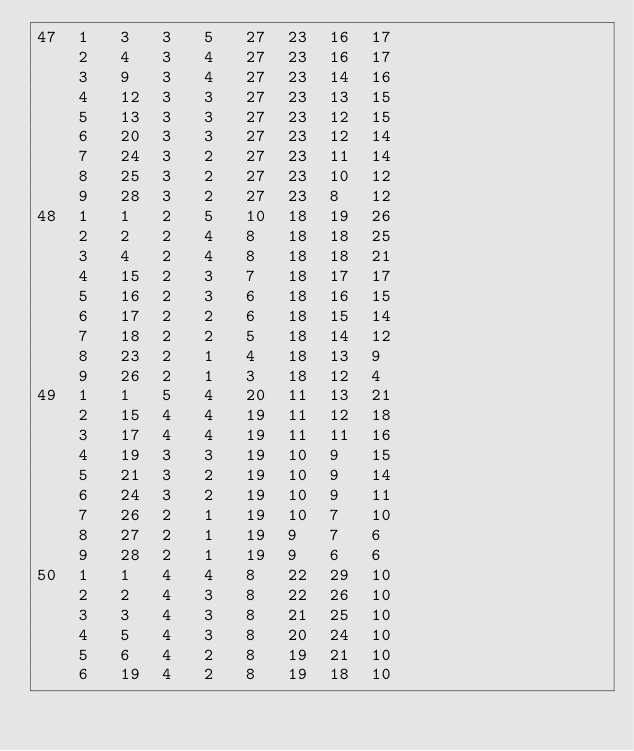Convert code to text. <code><loc_0><loc_0><loc_500><loc_500><_ObjectiveC_>47	1	3	3	5	27	23	16	17	
	2	4	3	4	27	23	16	17	
	3	9	3	4	27	23	14	16	
	4	12	3	3	27	23	13	15	
	5	13	3	3	27	23	12	15	
	6	20	3	3	27	23	12	14	
	7	24	3	2	27	23	11	14	
	8	25	3	2	27	23	10	12	
	9	28	3	2	27	23	8	12	
48	1	1	2	5	10	18	19	26	
	2	2	2	4	8	18	18	25	
	3	4	2	4	8	18	18	21	
	4	15	2	3	7	18	17	17	
	5	16	2	3	6	18	16	15	
	6	17	2	2	6	18	15	14	
	7	18	2	2	5	18	14	12	
	8	23	2	1	4	18	13	9	
	9	26	2	1	3	18	12	4	
49	1	1	5	4	20	11	13	21	
	2	15	4	4	19	11	12	18	
	3	17	4	4	19	11	11	16	
	4	19	3	3	19	10	9	15	
	5	21	3	2	19	10	9	14	
	6	24	3	2	19	10	9	11	
	7	26	2	1	19	10	7	10	
	8	27	2	1	19	9	7	6	
	9	28	2	1	19	9	6	6	
50	1	1	4	4	8	22	29	10	
	2	2	4	3	8	22	26	10	
	3	3	4	3	8	21	25	10	
	4	5	4	3	8	20	24	10	
	5	6	4	2	8	19	21	10	
	6	19	4	2	8	19	18	10	</code> 